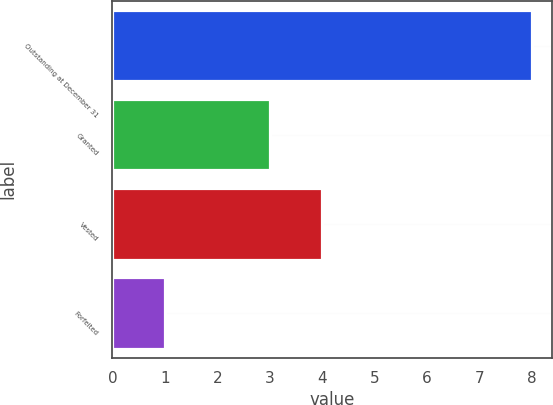Convert chart. <chart><loc_0><loc_0><loc_500><loc_500><bar_chart><fcel>Outstanding at December 31<fcel>Granted<fcel>Vested<fcel>Forfeited<nl><fcel>8<fcel>3<fcel>4<fcel>1<nl></chart> 